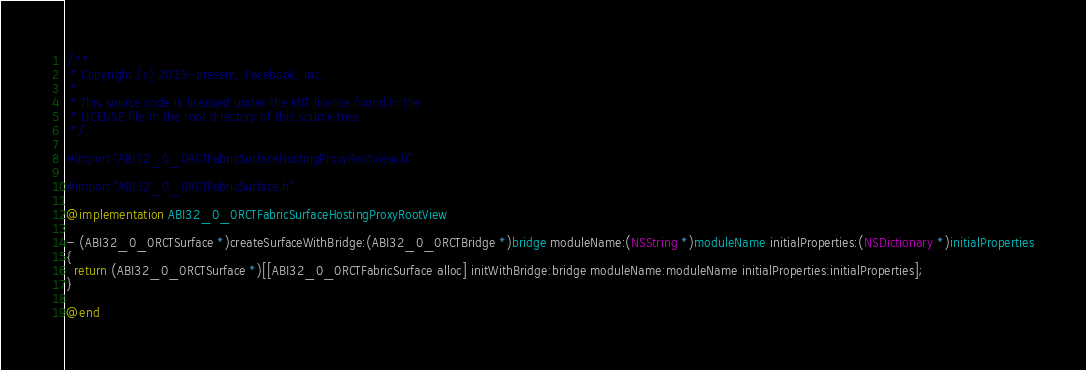<code> <loc_0><loc_0><loc_500><loc_500><_ObjectiveC_>/**
 * Copyright (c) 2015-present, Facebook, Inc.
 *
 * This source code is licensed under the MIT license found in the
 * LICENSE file in the root directory of this source tree.
 */

#import "ABI32_0_0RCTFabricSurfaceHostingProxyRootView.h"

#import "ABI32_0_0RCTFabricSurface.h"

@implementation ABI32_0_0RCTFabricSurfaceHostingProxyRootView

- (ABI32_0_0RCTSurface *)createSurfaceWithBridge:(ABI32_0_0RCTBridge *)bridge moduleName:(NSString *)moduleName initialProperties:(NSDictionary *)initialProperties
{
  return (ABI32_0_0RCTSurface *)[[ABI32_0_0RCTFabricSurface alloc] initWithBridge:bridge moduleName:moduleName initialProperties:initialProperties];
}

@end
</code> 